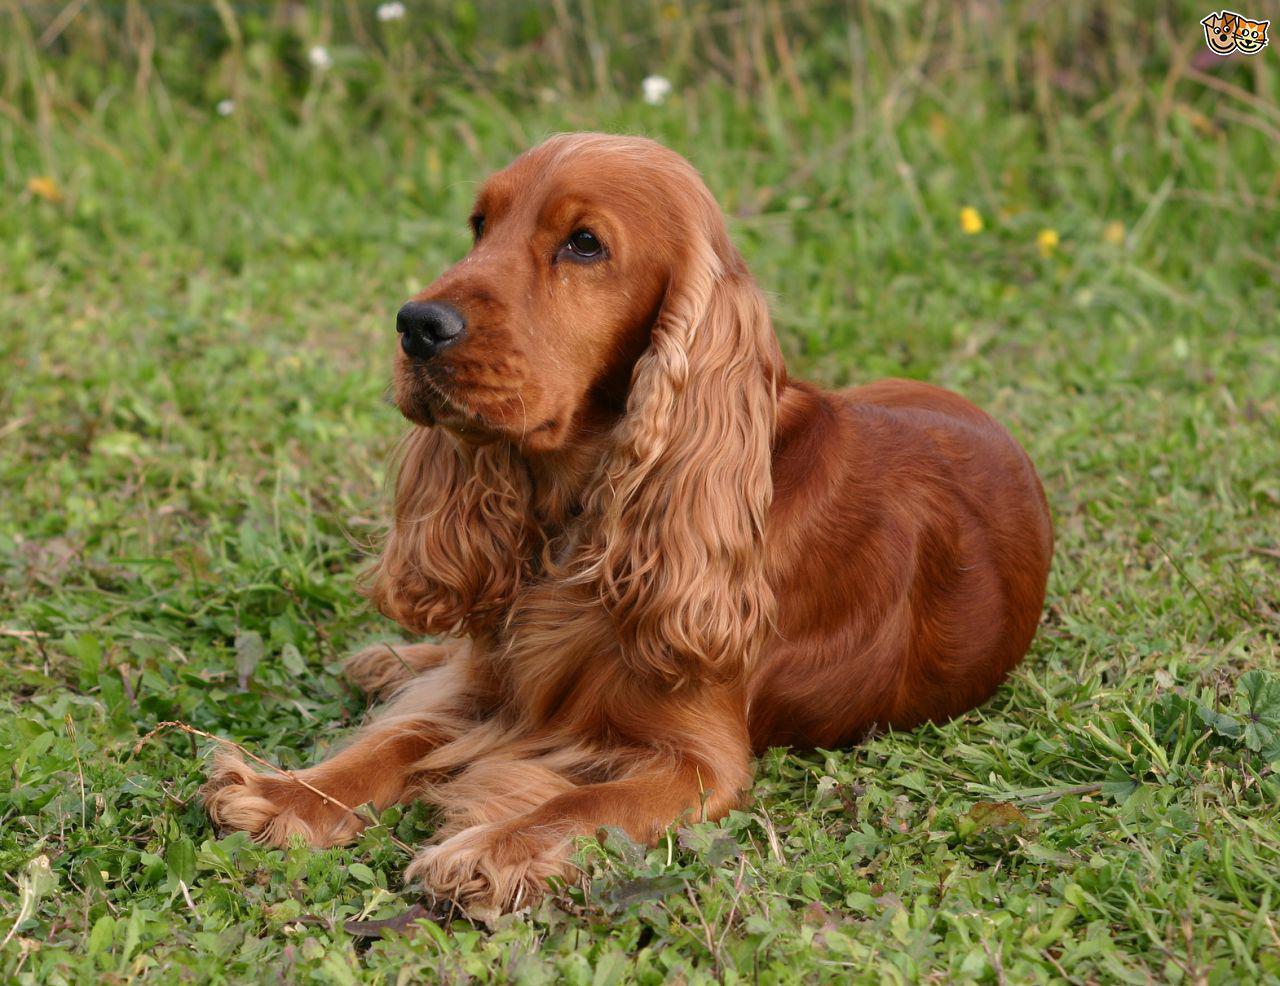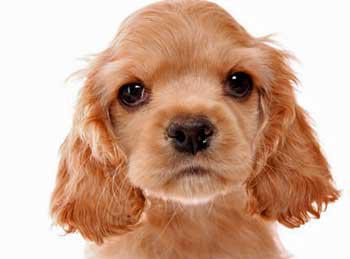The first image is the image on the left, the second image is the image on the right. Considering the images on both sides, is "One dog is on the grass, surrounded by grass." valid? Answer yes or no. Yes. 